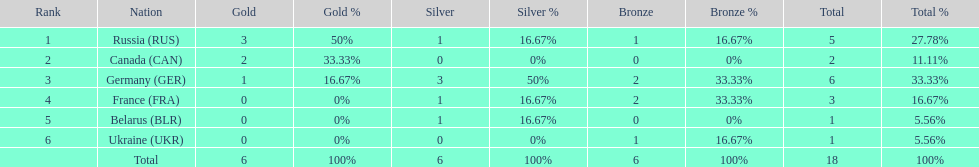Who had a larger total medal count, france or canada? France. 